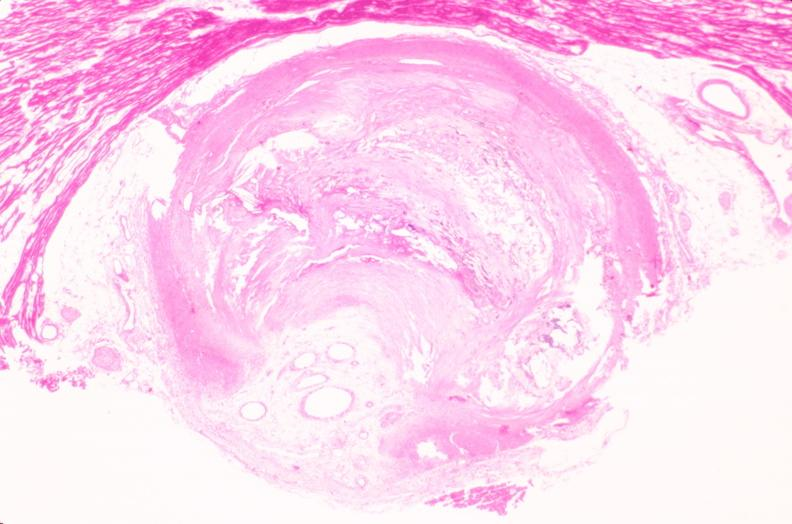s vasculature present?
Answer the question using a single word or phrase. Yes 